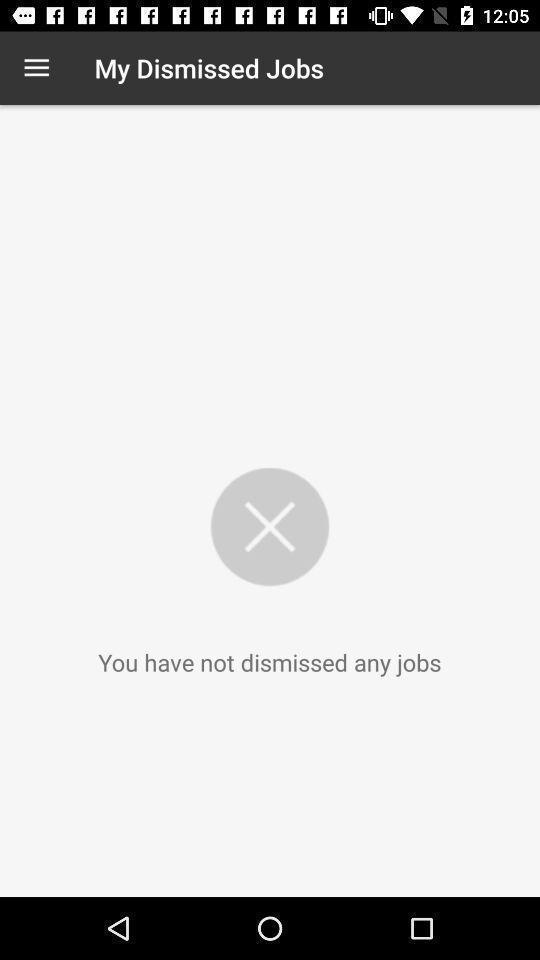Provide a textual representation of this image. Window displaying a job app. 